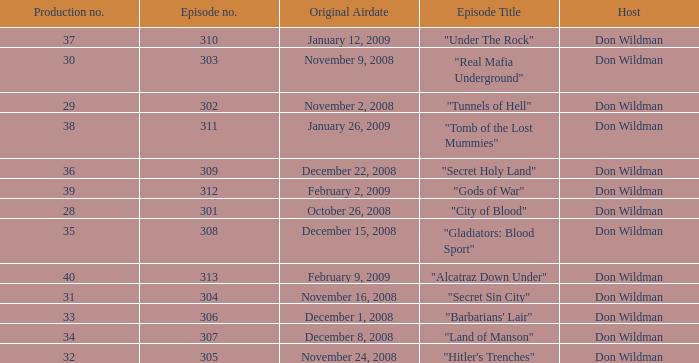What is the episode number of the episode that originally aired on January 26, 2009 and had a production number smaller than 38? 0.0. 